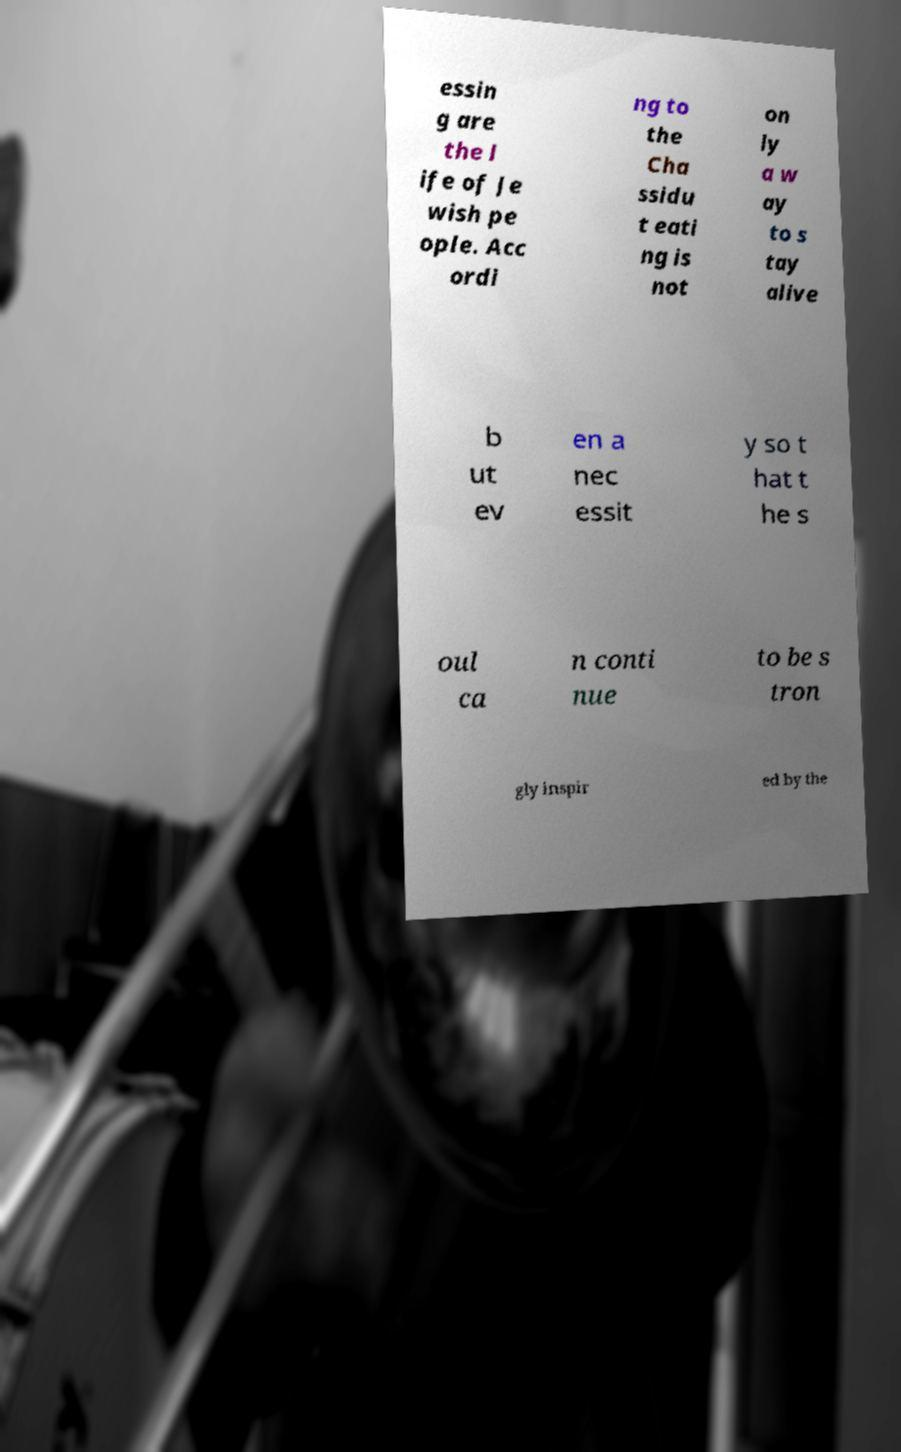Could you assist in decoding the text presented in this image and type it out clearly? essin g are the l ife of Je wish pe ople. Acc ordi ng to the Cha ssidu t eati ng is not on ly a w ay to s tay alive b ut ev en a nec essit y so t hat t he s oul ca n conti nue to be s tron gly inspir ed by the 